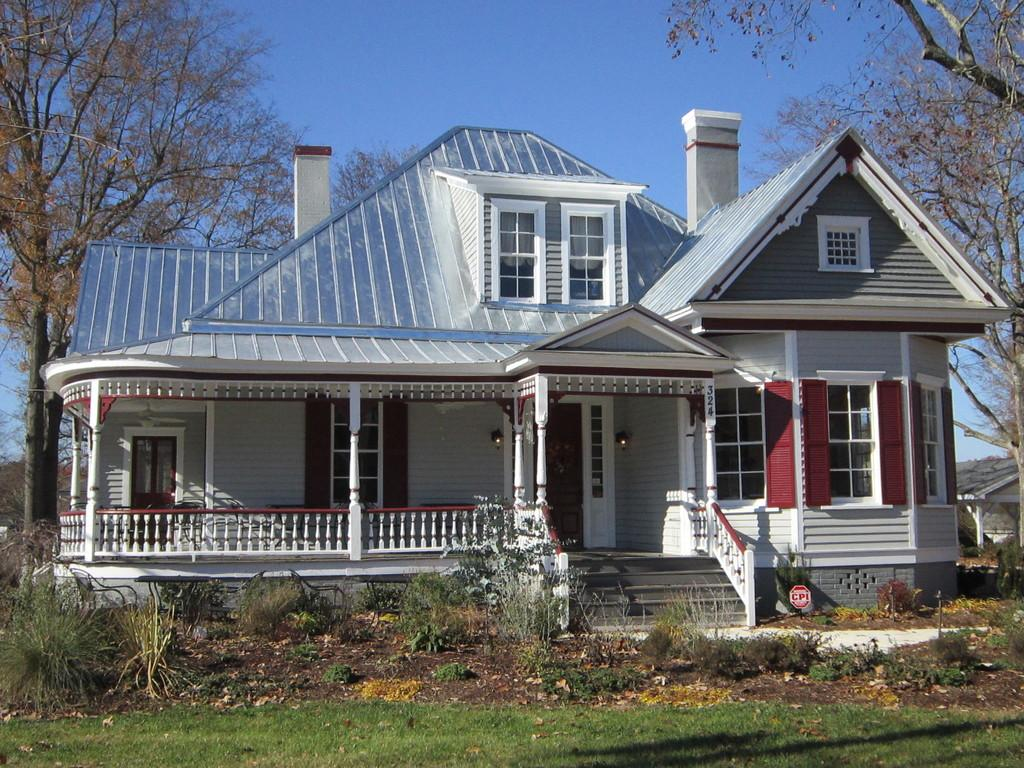What type of structure is present in the image? There is a house in the image. Where is the house located in relation to other elements in the image? The house is situated between trees. What other natural elements can be seen in the image? There are plants and grass visible in the image. What is visible at the top of the image? The sky is visible at the top of the image. Can you see a bee sitting on the seat of the gun in the image? There is no bee, seat, or gun present in the image. 